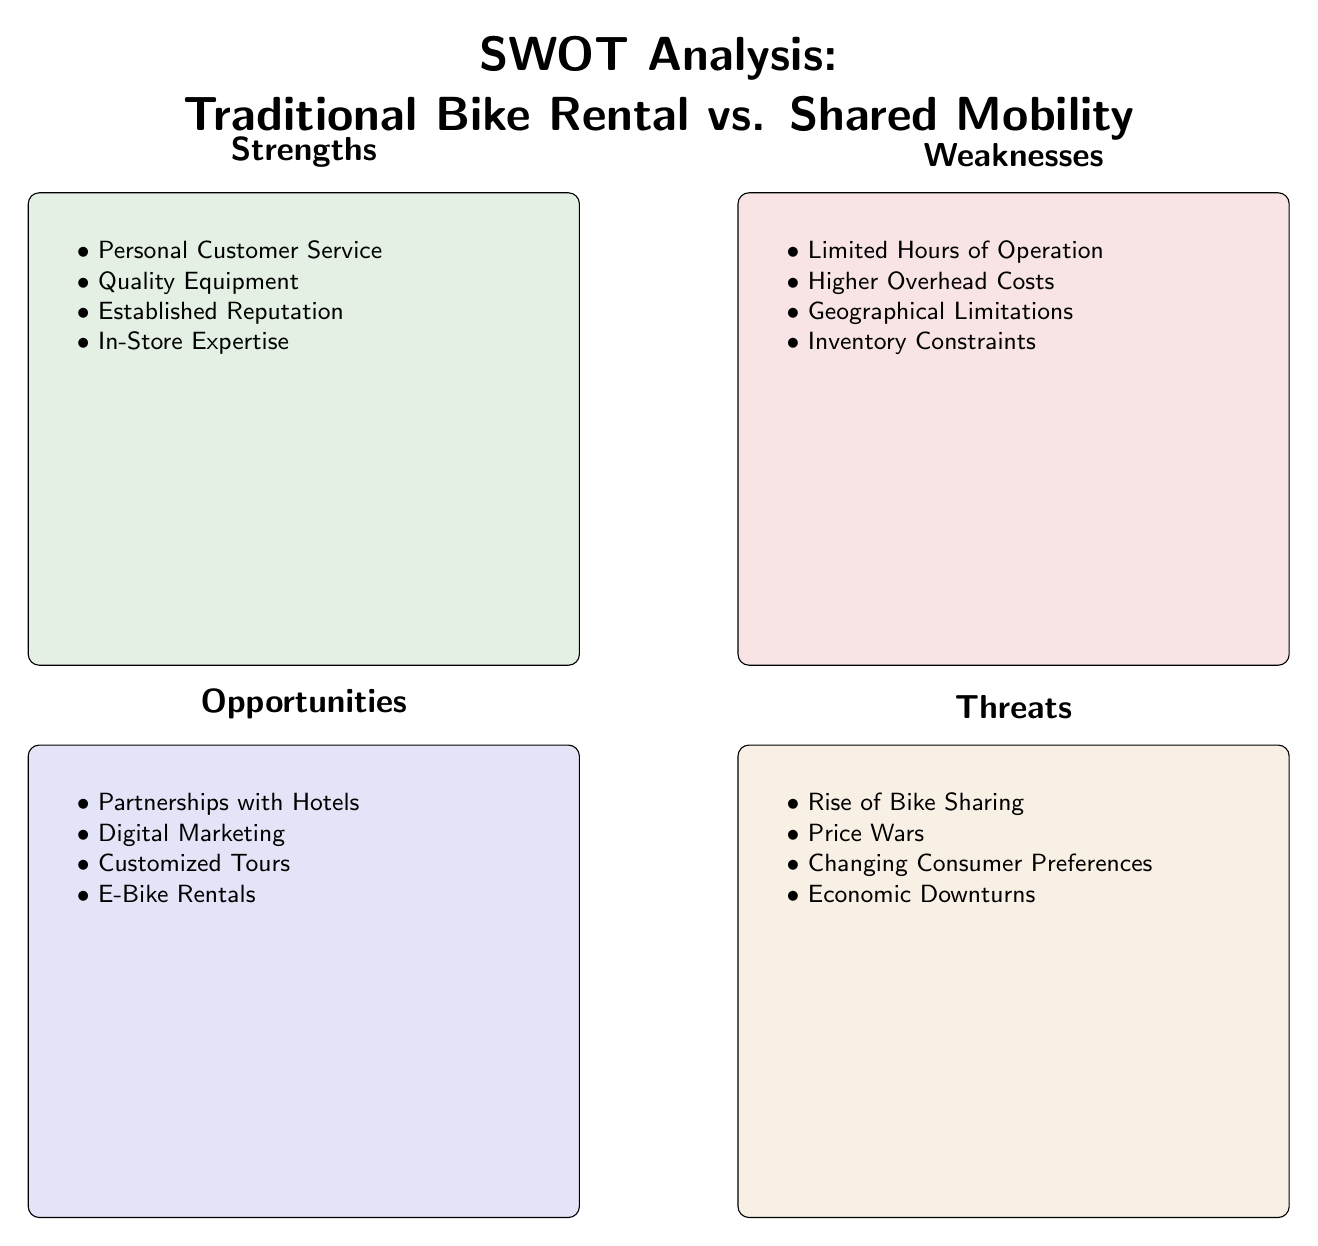What are the strengths of traditional bike rental businesses? The strengths are listed in the "Strengths" box of the diagram, which includes personal customer service, quality equipment, established reputation, and in-store expertise.
Answer: Personal Customer Service, Quality Equipment, Established Reputation, In-Store Expertise How many weaknesses are listed for traditional bike rental businesses? The weaknesses are found in the "Weaknesses" box, which outlines four specific weaknesses: limited hours of operation, higher overhead costs, geographical limitations, and inventory constraints. Counting them gives a total of four.
Answer: 4 Which opportunity mentions digital marketing? The "Opportunities" section in the diagram includes various items and specifically mentions digital marketing. This is one of the key opportunities identified for traditional bike rental businesses.
Answer: Digital Marketing What is the main threat posed by shared mobility services? The "Threats" section highlights several challenges, including the rise of bike sharing, which is a direct threat to traditional bike rental businesses. This factor is key in recognizing the impact of shared mobility services.
Answer: Rise of Bike Sharing What is the relationship between weaknesses and threats in this SWOT analysis? Both weaknesses and threats are identified in a separate box of the SWOT analysis. Weaknesses pertain to internal challenges within traditional bike rental businesses, while threats are external challenges posed by the market, particularly from shared mobility services.
Answer: Internal vs. External How many opportunities are noted for traditional bike rental businesses? The "Opportunities" section consists of four specific opportunities, including partnerships with hotels, digital marketing, customized tours, and e-bike rentals. Thus, the count of opportunities is four.
Answer: 4 Which specific threat addresses changing consumer preferences? The "Threats" box includes changing consumer preferences as one of its main points, indicating that traditional bike rental businesses must adapt to evolving customer needs.
Answer: Changing Consumer Preferences What is the overarching title of the diagram? The diagram features a central title that summarizes its content, specifically comparing traditional bike rental businesses to shared mobility services through a SWOT analysis. The title is shown prominently at the top of the diagram.
Answer: SWOT Analysis: Traditional Bike Rental vs. Shared Mobility 